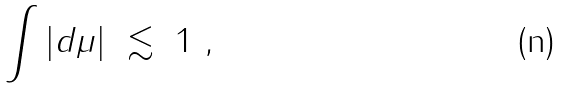Convert formula to latex. <formula><loc_0><loc_0><loc_500><loc_500>\int | d \mu | \ \lesssim \ 1 \ ,</formula> 